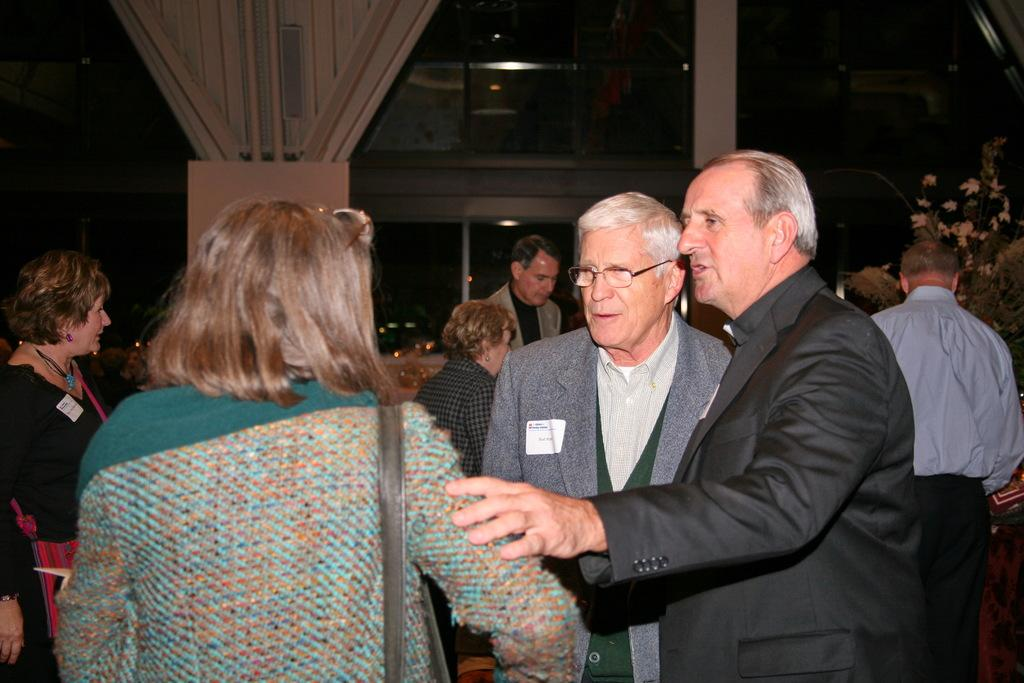How many people are in the group shown in the image? There is a group of people in the image, but the exact number is not specified. What are some people in the group wearing? Some people in the group are wearing bags. What type of building can be seen in the image? There is a glass building in the image. What other objects or elements are present in the image? Small plants are present in the image. What is the color of the background in the image? The background of the image is dark. What type of thread is being used to decorate the event in the image? There is no event or thread present in the image; it features a group of people, a glass building, small plants, and a dark background. What is the position of the moon in the image? There is no moon present in the image. 